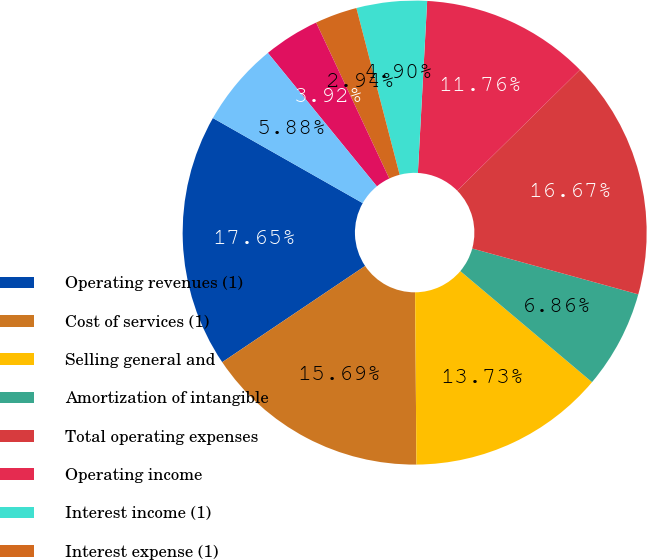<chart> <loc_0><loc_0><loc_500><loc_500><pie_chart><fcel>Operating revenues (1)<fcel>Cost of services (1)<fcel>Selling general and<fcel>Amortization of intangible<fcel>Total operating expenses<fcel>Operating income<fcel>Interest income (1)<fcel>Interest expense (1)<fcel>Other income<fcel>Interest and other income net<nl><fcel>17.65%<fcel>15.69%<fcel>13.73%<fcel>6.86%<fcel>16.67%<fcel>11.76%<fcel>4.9%<fcel>2.94%<fcel>3.92%<fcel>5.88%<nl></chart> 